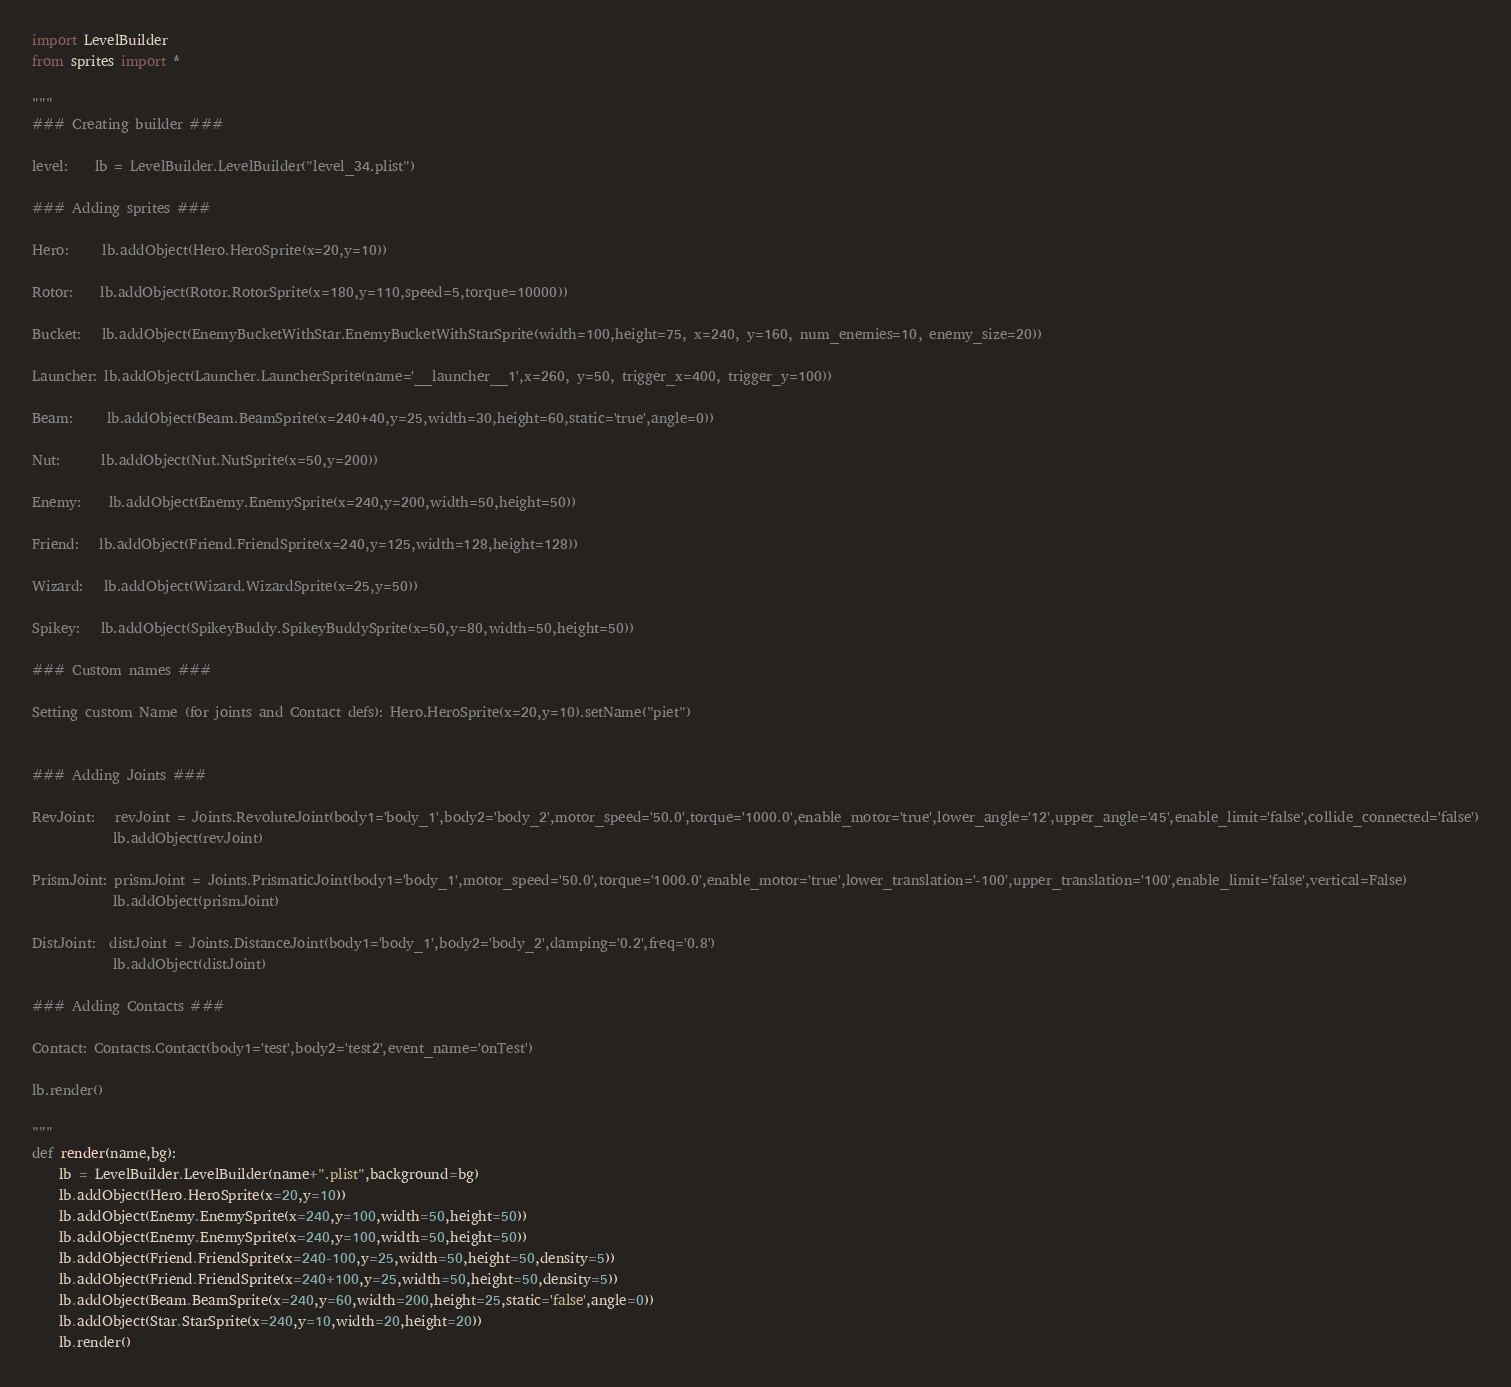Convert code to text. <code><loc_0><loc_0><loc_500><loc_500><_Python_>import LevelBuilder
from sprites import *

"""
### Creating builder ###

level:    lb = LevelBuilder.LevelBuilder("level_34.plist")

### Adding sprites ###

Hero:     lb.addObject(Hero.HeroSprite(x=20,y=10))

Rotor:    lb.addObject(Rotor.RotorSprite(x=180,y=110,speed=5,torque=10000))

Bucket:   lb.addObject(EnemyBucketWithStar.EnemyBucketWithStarSprite(width=100,height=75, x=240, y=160, num_enemies=10, enemy_size=20))

Launcher: lb.addObject(Launcher.LauncherSprite(name='__launcher__1',x=260, y=50, trigger_x=400, trigger_y=100))

Beam:     lb.addObject(Beam.BeamSprite(x=240+40,y=25,width=30,height=60,static='true',angle=0))

Nut:      lb.addObject(Nut.NutSprite(x=50,y=200))

Enemy:    lb.addObject(Enemy.EnemySprite(x=240,y=200,width=50,height=50))

Friend:   lb.addObject(Friend.FriendSprite(x=240,y=125,width=128,height=128))

Wizard:   lb.addObject(Wizard.WizardSprite(x=25,y=50))

Spikey:   lb.addObject(SpikeyBuddy.SpikeyBuddySprite(x=50,y=80,width=50,height=50))

### Custom names ###

Setting custom Name (for joints and Contact defs): Hero.HeroSprite(x=20,y=10).setName("piet")


### Adding Joints ###

RevJoint:   revJoint = Joints.RevoluteJoint(body1='body_1',body2='body_2',motor_speed='50.0',torque='1000.0',enable_motor='true',lower_angle='12',upper_angle='45',enable_limit='false',collide_connected='false')
            lb.addObject(revJoint)
          
PrismJoint: prismJoint = Joints.PrismaticJoint(body1='body_1',motor_speed='50.0',torque='1000.0',enable_motor='true',lower_translation='-100',upper_translation='100',enable_limit='false',vertical=False)
            lb.addObject(prismJoint)
            
DistJoint:  distJoint = Joints.DistanceJoint(body1='body_1',body2='body_2',damping='0.2',freq='0.8')   
            lb.addObject(distJoint)
            
### Adding Contacts ###

Contact: Contacts.Contact(body1='test',body2='test2',event_name='onTest')
            
lb.render()

"""
def render(name,bg):
    lb = LevelBuilder.LevelBuilder(name+".plist",background=bg)
    lb.addObject(Hero.HeroSprite(x=20,y=10))
    lb.addObject(Enemy.EnemySprite(x=240,y=100,width=50,height=50))
    lb.addObject(Enemy.EnemySprite(x=240,y=100,width=50,height=50))
    lb.addObject(Friend.FriendSprite(x=240-100,y=25,width=50,height=50,density=5))
    lb.addObject(Friend.FriendSprite(x=240+100,y=25,width=50,height=50,density=5))
    lb.addObject(Beam.BeamSprite(x=240,y=60,width=200,height=25,static='false',angle=0))
    lb.addObject(Star.StarSprite(x=240,y=10,width=20,height=20))
    lb.render()
</code> 